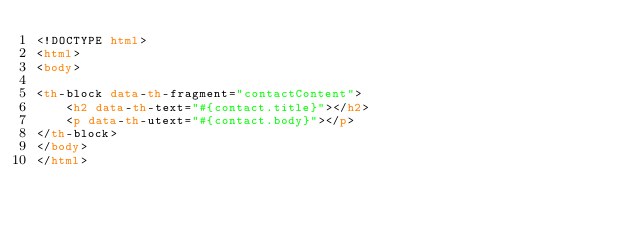Convert code to text. <code><loc_0><loc_0><loc_500><loc_500><_HTML_><!DOCTYPE html>
<html>
<body>

<th-block data-th-fragment="contactContent">
    <h2 data-th-text="#{contact.title}"></h2>
    <p data-th-utext="#{contact.body}"></p>
</th-block>
</body>
</html></code> 